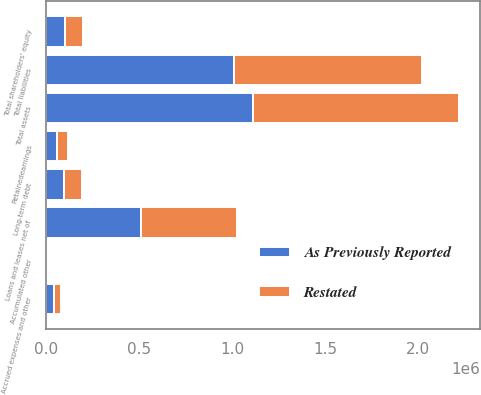Convert chart. <chart><loc_0><loc_0><loc_500><loc_500><stacked_bar_chart><ecel><fcel>Loans and leases net of<fcel>Total assets<fcel>Accrued expenses and other<fcel>Long-term debt<fcel>Total liabilities<fcel>Retainedearnings<fcel>Accumulated other<fcel>Total shareholders' equity<nl><fcel>As Previously Reported<fcel>513211<fcel>1.11046e+06<fcel>41243<fcel>98078<fcel>1.01081e+06<fcel>58006<fcel>2587<fcel>99645<nl><fcel>Restated<fcel>513187<fcel>1.11043e+06<fcel>41590<fcel>97116<fcel>1.0102e+06<fcel>58773<fcel>2764<fcel>100235<nl></chart> 